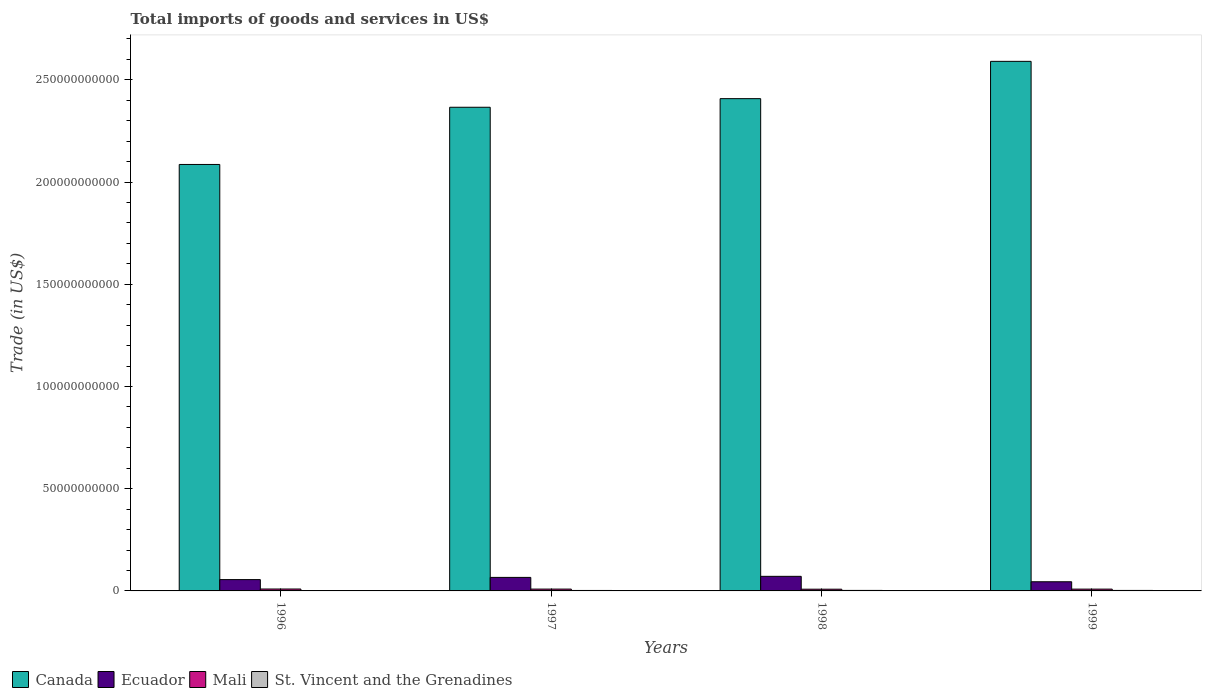How many groups of bars are there?
Keep it short and to the point. 4. How many bars are there on the 4th tick from the right?
Offer a terse response. 4. What is the label of the 3rd group of bars from the left?
Offer a very short reply. 1998. In how many cases, is the number of bars for a given year not equal to the number of legend labels?
Offer a very short reply. 0. What is the total imports of goods and services in Mali in 1998?
Make the answer very short. 8.45e+08. Across all years, what is the maximum total imports of goods and services in Canada?
Give a very brief answer. 2.59e+11. Across all years, what is the minimum total imports of goods and services in Ecuador?
Provide a short and direct response. 4.48e+09. In which year was the total imports of goods and services in Ecuador minimum?
Your response must be concise. 1999. What is the total total imports of goods and services in St. Vincent and the Grenadines in the graph?
Your answer should be compact. 9.04e+08. What is the difference between the total imports of goods and services in Ecuador in 1997 and that in 1999?
Offer a terse response. 2.13e+09. What is the difference between the total imports of goods and services in Ecuador in 1996 and the total imports of goods and services in Mali in 1999?
Provide a short and direct response. 4.65e+09. What is the average total imports of goods and services in St. Vincent and the Grenadines per year?
Offer a very short reply. 2.26e+08. In the year 1999, what is the difference between the total imports of goods and services in Ecuador and total imports of goods and services in Canada?
Offer a terse response. -2.55e+11. In how many years, is the total imports of goods and services in Canada greater than 180000000000 US$?
Your answer should be very brief. 4. What is the ratio of the total imports of goods and services in St. Vincent and the Grenadines in 1996 to that in 1997?
Your answer should be compact. 0.81. Is the difference between the total imports of goods and services in Ecuador in 1996 and 1998 greater than the difference between the total imports of goods and services in Canada in 1996 and 1998?
Offer a very short reply. Yes. What is the difference between the highest and the second highest total imports of goods and services in St. Vincent and the Grenadines?
Provide a short and direct response. 9.04e+06. What is the difference between the highest and the lowest total imports of goods and services in Canada?
Your answer should be compact. 5.04e+1. In how many years, is the total imports of goods and services in Canada greater than the average total imports of goods and services in Canada taken over all years?
Your answer should be very brief. 3. What does the 3rd bar from the right in 1996 represents?
Your answer should be compact. Ecuador. How many bars are there?
Offer a very short reply. 16. How many years are there in the graph?
Offer a terse response. 4. Does the graph contain any zero values?
Give a very brief answer. No. Where does the legend appear in the graph?
Your answer should be very brief. Bottom left. How many legend labels are there?
Keep it short and to the point. 4. What is the title of the graph?
Your answer should be compact. Total imports of goods and services in US$. What is the label or title of the Y-axis?
Your answer should be very brief. Trade (in US$). What is the Trade (in US$) of Canada in 1996?
Keep it short and to the point. 2.09e+11. What is the Trade (in US$) of Ecuador in 1996?
Provide a succinct answer. 5.54e+09. What is the Trade (in US$) in Mali in 1996?
Provide a succinct answer. 9.35e+08. What is the Trade (in US$) of St. Vincent and the Grenadines in 1996?
Your response must be concise. 1.86e+08. What is the Trade (in US$) in Canada in 1997?
Your answer should be very brief. 2.37e+11. What is the Trade (in US$) of Ecuador in 1997?
Offer a terse response. 6.61e+09. What is the Trade (in US$) in Mali in 1997?
Ensure brevity in your answer.  8.96e+08. What is the Trade (in US$) of St. Vincent and the Grenadines in 1997?
Ensure brevity in your answer.  2.29e+08. What is the Trade (in US$) in Canada in 1998?
Offer a terse response. 2.41e+11. What is the Trade (in US$) of Ecuador in 1998?
Provide a short and direct response. 7.14e+09. What is the Trade (in US$) of Mali in 1998?
Your response must be concise. 8.45e+08. What is the Trade (in US$) of St. Vincent and the Grenadines in 1998?
Provide a short and direct response. 2.49e+08. What is the Trade (in US$) of Canada in 1999?
Ensure brevity in your answer.  2.59e+11. What is the Trade (in US$) in Ecuador in 1999?
Give a very brief answer. 4.48e+09. What is the Trade (in US$) of Mali in 1999?
Provide a succinct answer. 8.84e+08. What is the Trade (in US$) in St. Vincent and the Grenadines in 1999?
Give a very brief answer. 2.40e+08. Across all years, what is the maximum Trade (in US$) of Canada?
Offer a terse response. 2.59e+11. Across all years, what is the maximum Trade (in US$) in Ecuador?
Keep it short and to the point. 7.14e+09. Across all years, what is the maximum Trade (in US$) in Mali?
Your response must be concise. 9.35e+08. Across all years, what is the maximum Trade (in US$) in St. Vincent and the Grenadines?
Offer a very short reply. 2.49e+08. Across all years, what is the minimum Trade (in US$) in Canada?
Provide a short and direct response. 2.09e+11. Across all years, what is the minimum Trade (in US$) in Ecuador?
Offer a very short reply. 4.48e+09. Across all years, what is the minimum Trade (in US$) of Mali?
Keep it short and to the point. 8.45e+08. Across all years, what is the minimum Trade (in US$) of St. Vincent and the Grenadines?
Provide a succinct answer. 1.86e+08. What is the total Trade (in US$) of Canada in the graph?
Give a very brief answer. 9.45e+11. What is the total Trade (in US$) in Ecuador in the graph?
Offer a very short reply. 2.38e+1. What is the total Trade (in US$) in Mali in the graph?
Keep it short and to the point. 3.56e+09. What is the total Trade (in US$) in St. Vincent and the Grenadines in the graph?
Provide a succinct answer. 9.04e+08. What is the difference between the Trade (in US$) of Canada in 1996 and that in 1997?
Keep it short and to the point. -2.80e+1. What is the difference between the Trade (in US$) in Ecuador in 1996 and that in 1997?
Provide a short and direct response. -1.08e+09. What is the difference between the Trade (in US$) of Mali in 1996 and that in 1997?
Your response must be concise. 3.91e+07. What is the difference between the Trade (in US$) of St. Vincent and the Grenadines in 1996 and that in 1997?
Give a very brief answer. -4.27e+07. What is the difference between the Trade (in US$) in Canada in 1996 and that in 1998?
Your response must be concise. -3.22e+1. What is the difference between the Trade (in US$) in Ecuador in 1996 and that in 1998?
Make the answer very short. -1.60e+09. What is the difference between the Trade (in US$) of Mali in 1996 and that in 1998?
Offer a terse response. 9.02e+07. What is the difference between the Trade (in US$) of St. Vincent and the Grenadines in 1996 and that in 1998?
Provide a succinct answer. -6.27e+07. What is the difference between the Trade (in US$) of Canada in 1996 and that in 1999?
Give a very brief answer. -5.04e+1. What is the difference between the Trade (in US$) of Ecuador in 1996 and that in 1999?
Your response must be concise. 1.05e+09. What is the difference between the Trade (in US$) in Mali in 1996 and that in 1999?
Make the answer very short. 5.07e+07. What is the difference between the Trade (in US$) in St. Vincent and the Grenadines in 1996 and that in 1999?
Ensure brevity in your answer.  -5.37e+07. What is the difference between the Trade (in US$) of Canada in 1997 and that in 1998?
Offer a very short reply. -4.21e+09. What is the difference between the Trade (in US$) in Ecuador in 1997 and that in 1998?
Ensure brevity in your answer.  -5.23e+08. What is the difference between the Trade (in US$) in Mali in 1997 and that in 1998?
Provide a succinct answer. 5.10e+07. What is the difference between the Trade (in US$) of St. Vincent and the Grenadines in 1997 and that in 1998?
Make the answer very short. -2.01e+07. What is the difference between the Trade (in US$) of Canada in 1997 and that in 1999?
Offer a very short reply. -2.25e+1. What is the difference between the Trade (in US$) in Ecuador in 1997 and that in 1999?
Provide a short and direct response. 2.13e+09. What is the difference between the Trade (in US$) of Mali in 1997 and that in 1999?
Provide a succinct answer. 1.15e+07. What is the difference between the Trade (in US$) in St. Vincent and the Grenadines in 1997 and that in 1999?
Keep it short and to the point. -1.10e+07. What is the difference between the Trade (in US$) of Canada in 1998 and that in 1999?
Provide a succinct answer. -1.82e+1. What is the difference between the Trade (in US$) of Ecuador in 1998 and that in 1999?
Offer a terse response. 2.65e+09. What is the difference between the Trade (in US$) of Mali in 1998 and that in 1999?
Your response must be concise. -3.95e+07. What is the difference between the Trade (in US$) in St. Vincent and the Grenadines in 1998 and that in 1999?
Give a very brief answer. 9.04e+06. What is the difference between the Trade (in US$) in Canada in 1996 and the Trade (in US$) in Ecuador in 1997?
Your answer should be very brief. 2.02e+11. What is the difference between the Trade (in US$) of Canada in 1996 and the Trade (in US$) of Mali in 1997?
Your answer should be compact. 2.08e+11. What is the difference between the Trade (in US$) of Canada in 1996 and the Trade (in US$) of St. Vincent and the Grenadines in 1997?
Your answer should be very brief. 2.08e+11. What is the difference between the Trade (in US$) of Ecuador in 1996 and the Trade (in US$) of Mali in 1997?
Provide a short and direct response. 4.64e+09. What is the difference between the Trade (in US$) in Ecuador in 1996 and the Trade (in US$) in St. Vincent and the Grenadines in 1997?
Ensure brevity in your answer.  5.31e+09. What is the difference between the Trade (in US$) of Mali in 1996 and the Trade (in US$) of St. Vincent and the Grenadines in 1997?
Your answer should be very brief. 7.06e+08. What is the difference between the Trade (in US$) in Canada in 1996 and the Trade (in US$) in Ecuador in 1998?
Give a very brief answer. 2.01e+11. What is the difference between the Trade (in US$) in Canada in 1996 and the Trade (in US$) in Mali in 1998?
Your answer should be compact. 2.08e+11. What is the difference between the Trade (in US$) in Canada in 1996 and the Trade (in US$) in St. Vincent and the Grenadines in 1998?
Offer a terse response. 2.08e+11. What is the difference between the Trade (in US$) in Ecuador in 1996 and the Trade (in US$) in Mali in 1998?
Your answer should be very brief. 4.69e+09. What is the difference between the Trade (in US$) in Ecuador in 1996 and the Trade (in US$) in St. Vincent and the Grenadines in 1998?
Your answer should be compact. 5.29e+09. What is the difference between the Trade (in US$) in Mali in 1996 and the Trade (in US$) in St. Vincent and the Grenadines in 1998?
Ensure brevity in your answer.  6.86e+08. What is the difference between the Trade (in US$) in Canada in 1996 and the Trade (in US$) in Ecuador in 1999?
Ensure brevity in your answer.  2.04e+11. What is the difference between the Trade (in US$) of Canada in 1996 and the Trade (in US$) of Mali in 1999?
Your response must be concise. 2.08e+11. What is the difference between the Trade (in US$) of Canada in 1996 and the Trade (in US$) of St. Vincent and the Grenadines in 1999?
Your answer should be very brief. 2.08e+11. What is the difference between the Trade (in US$) in Ecuador in 1996 and the Trade (in US$) in Mali in 1999?
Offer a very short reply. 4.65e+09. What is the difference between the Trade (in US$) of Ecuador in 1996 and the Trade (in US$) of St. Vincent and the Grenadines in 1999?
Keep it short and to the point. 5.30e+09. What is the difference between the Trade (in US$) of Mali in 1996 and the Trade (in US$) of St. Vincent and the Grenadines in 1999?
Your response must be concise. 6.95e+08. What is the difference between the Trade (in US$) in Canada in 1997 and the Trade (in US$) in Ecuador in 1998?
Keep it short and to the point. 2.29e+11. What is the difference between the Trade (in US$) of Canada in 1997 and the Trade (in US$) of Mali in 1998?
Make the answer very short. 2.36e+11. What is the difference between the Trade (in US$) in Canada in 1997 and the Trade (in US$) in St. Vincent and the Grenadines in 1998?
Ensure brevity in your answer.  2.36e+11. What is the difference between the Trade (in US$) in Ecuador in 1997 and the Trade (in US$) in Mali in 1998?
Make the answer very short. 5.77e+09. What is the difference between the Trade (in US$) in Ecuador in 1997 and the Trade (in US$) in St. Vincent and the Grenadines in 1998?
Provide a short and direct response. 6.36e+09. What is the difference between the Trade (in US$) of Mali in 1997 and the Trade (in US$) of St. Vincent and the Grenadines in 1998?
Provide a short and direct response. 6.47e+08. What is the difference between the Trade (in US$) of Canada in 1997 and the Trade (in US$) of Ecuador in 1999?
Make the answer very short. 2.32e+11. What is the difference between the Trade (in US$) in Canada in 1997 and the Trade (in US$) in Mali in 1999?
Keep it short and to the point. 2.36e+11. What is the difference between the Trade (in US$) in Canada in 1997 and the Trade (in US$) in St. Vincent and the Grenadines in 1999?
Provide a short and direct response. 2.36e+11. What is the difference between the Trade (in US$) in Ecuador in 1997 and the Trade (in US$) in Mali in 1999?
Keep it short and to the point. 5.73e+09. What is the difference between the Trade (in US$) of Ecuador in 1997 and the Trade (in US$) of St. Vincent and the Grenadines in 1999?
Your answer should be very brief. 6.37e+09. What is the difference between the Trade (in US$) in Mali in 1997 and the Trade (in US$) in St. Vincent and the Grenadines in 1999?
Ensure brevity in your answer.  6.56e+08. What is the difference between the Trade (in US$) in Canada in 1998 and the Trade (in US$) in Ecuador in 1999?
Offer a very short reply. 2.36e+11. What is the difference between the Trade (in US$) of Canada in 1998 and the Trade (in US$) of Mali in 1999?
Offer a terse response. 2.40e+11. What is the difference between the Trade (in US$) of Canada in 1998 and the Trade (in US$) of St. Vincent and the Grenadines in 1999?
Give a very brief answer. 2.41e+11. What is the difference between the Trade (in US$) in Ecuador in 1998 and the Trade (in US$) in Mali in 1999?
Your answer should be very brief. 6.25e+09. What is the difference between the Trade (in US$) in Ecuador in 1998 and the Trade (in US$) in St. Vincent and the Grenadines in 1999?
Offer a very short reply. 6.90e+09. What is the difference between the Trade (in US$) of Mali in 1998 and the Trade (in US$) of St. Vincent and the Grenadines in 1999?
Provide a short and direct response. 6.05e+08. What is the average Trade (in US$) of Canada per year?
Offer a very short reply. 2.36e+11. What is the average Trade (in US$) in Ecuador per year?
Keep it short and to the point. 5.94e+09. What is the average Trade (in US$) of Mali per year?
Offer a terse response. 8.90e+08. What is the average Trade (in US$) in St. Vincent and the Grenadines per year?
Provide a succinct answer. 2.26e+08. In the year 1996, what is the difference between the Trade (in US$) of Canada and Trade (in US$) of Ecuador?
Give a very brief answer. 2.03e+11. In the year 1996, what is the difference between the Trade (in US$) of Canada and Trade (in US$) of Mali?
Provide a short and direct response. 2.08e+11. In the year 1996, what is the difference between the Trade (in US$) of Canada and Trade (in US$) of St. Vincent and the Grenadines?
Offer a very short reply. 2.08e+11. In the year 1996, what is the difference between the Trade (in US$) in Ecuador and Trade (in US$) in Mali?
Offer a very short reply. 4.60e+09. In the year 1996, what is the difference between the Trade (in US$) in Ecuador and Trade (in US$) in St. Vincent and the Grenadines?
Ensure brevity in your answer.  5.35e+09. In the year 1996, what is the difference between the Trade (in US$) of Mali and Trade (in US$) of St. Vincent and the Grenadines?
Provide a succinct answer. 7.49e+08. In the year 1997, what is the difference between the Trade (in US$) in Canada and Trade (in US$) in Ecuador?
Keep it short and to the point. 2.30e+11. In the year 1997, what is the difference between the Trade (in US$) of Canada and Trade (in US$) of Mali?
Keep it short and to the point. 2.36e+11. In the year 1997, what is the difference between the Trade (in US$) in Canada and Trade (in US$) in St. Vincent and the Grenadines?
Offer a very short reply. 2.36e+11. In the year 1997, what is the difference between the Trade (in US$) of Ecuador and Trade (in US$) of Mali?
Offer a very short reply. 5.72e+09. In the year 1997, what is the difference between the Trade (in US$) of Ecuador and Trade (in US$) of St. Vincent and the Grenadines?
Provide a short and direct response. 6.38e+09. In the year 1997, what is the difference between the Trade (in US$) of Mali and Trade (in US$) of St. Vincent and the Grenadines?
Ensure brevity in your answer.  6.67e+08. In the year 1998, what is the difference between the Trade (in US$) of Canada and Trade (in US$) of Ecuador?
Provide a succinct answer. 2.34e+11. In the year 1998, what is the difference between the Trade (in US$) in Canada and Trade (in US$) in Mali?
Give a very brief answer. 2.40e+11. In the year 1998, what is the difference between the Trade (in US$) in Canada and Trade (in US$) in St. Vincent and the Grenadines?
Provide a succinct answer. 2.41e+11. In the year 1998, what is the difference between the Trade (in US$) in Ecuador and Trade (in US$) in Mali?
Give a very brief answer. 6.29e+09. In the year 1998, what is the difference between the Trade (in US$) in Ecuador and Trade (in US$) in St. Vincent and the Grenadines?
Provide a short and direct response. 6.89e+09. In the year 1998, what is the difference between the Trade (in US$) of Mali and Trade (in US$) of St. Vincent and the Grenadines?
Give a very brief answer. 5.96e+08. In the year 1999, what is the difference between the Trade (in US$) of Canada and Trade (in US$) of Ecuador?
Give a very brief answer. 2.55e+11. In the year 1999, what is the difference between the Trade (in US$) in Canada and Trade (in US$) in Mali?
Keep it short and to the point. 2.58e+11. In the year 1999, what is the difference between the Trade (in US$) of Canada and Trade (in US$) of St. Vincent and the Grenadines?
Offer a very short reply. 2.59e+11. In the year 1999, what is the difference between the Trade (in US$) of Ecuador and Trade (in US$) of Mali?
Your answer should be very brief. 3.60e+09. In the year 1999, what is the difference between the Trade (in US$) of Ecuador and Trade (in US$) of St. Vincent and the Grenadines?
Ensure brevity in your answer.  4.24e+09. In the year 1999, what is the difference between the Trade (in US$) in Mali and Trade (in US$) in St. Vincent and the Grenadines?
Your answer should be compact. 6.44e+08. What is the ratio of the Trade (in US$) in Canada in 1996 to that in 1997?
Make the answer very short. 0.88. What is the ratio of the Trade (in US$) of Ecuador in 1996 to that in 1997?
Ensure brevity in your answer.  0.84. What is the ratio of the Trade (in US$) of Mali in 1996 to that in 1997?
Provide a short and direct response. 1.04. What is the ratio of the Trade (in US$) of St. Vincent and the Grenadines in 1996 to that in 1997?
Your answer should be very brief. 0.81. What is the ratio of the Trade (in US$) in Canada in 1996 to that in 1998?
Give a very brief answer. 0.87. What is the ratio of the Trade (in US$) of Ecuador in 1996 to that in 1998?
Your answer should be very brief. 0.78. What is the ratio of the Trade (in US$) in Mali in 1996 to that in 1998?
Your response must be concise. 1.11. What is the ratio of the Trade (in US$) in St. Vincent and the Grenadines in 1996 to that in 1998?
Provide a short and direct response. 0.75. What is the ratio of the Trade (in US$) of Canada in 1996 to that in 1999?
Make the answer very short. 0.81. What is the ratio of the Trade (in US$) in Ecuador in 1996 to that in 1999?
Make the answer very short. 1.23. What is the ratio of the Trade (in US$) of Mali in 1996 to that in 1999?
Keep it short and to the point. 1.06. What is the ratio of the Trade (in US$) of St. Vincent and the Grenadines in 1996 to that in 1999?
Provide a succinct answer. 0.78. What is the ratio of the Trade (in US$) in Canada in 1997 to that in 1998?
Offer a very short reply. 0.98. What is the ratio of the Trade (in US$) in Ecuador in 1997 to that in 1998?
Keep it short and to the point. 0.93. What is the ratio of the Trade (in US$) in Mali in 1997 to that in 1998?
Your answer should be very brief. 1.06. What is the ratio of the Trade (in US$) in St. Vincent and the Grenadines in 1997 to that in 1998?
Your answer should be compact. 0.92. What is the ratio of the Trade (in US$) in Canada in 1997 to that in 1999?
Provide a succinct answer. 0.91. What is the ratio of the Trade (in US$) in Ecuador in 1997 to that in 1999?
Provide a short and direct response. 1.47. What is the ratio of the Trade (in US$) of Mali in 1997 to that in 1999?
Keep it short and to the point. 1.01. What is the ratio of the Trade (in US$) in St. Vincent and the Grenadines in 1997 to that in 1999?
Give a very brief answer. 0.95. What is the ratio of the Trade (in US$) in Canada in 1998 to that in 1999?
Make the answer very short. 0.93. What is the ratio of the Trade (in US$) of Ecuador in 1998 to that in 1999?
Give a very brief answer. 1.59. What is the ratio of the Trade (in US$) in Mali in 1998 to that in 1999?
Give a very brief answer. 0.96. What is the ratio of the Trade (in US$) of St. Vincent and the Grenadines in 1998 to that in 1999?
Provide a short and direct response. 1.04. What is the difference between the highest and the second highest Trade (in US$) of Canada?
Your answer should be very brief. 1.82e+1. What is the difference between the highest and the second highest Trade (in US$) of Ecuador?
Ensure brevity in your answer.  5.23e+08. What is the difference between the highest and the second highest Trade (in US$) in Mali?
Keep it short and to the point. 3.91e+07. What is the difference between the highest and the second highest Trade (in US$) of St. Vincent and the Grenadines?
Make the answer very short. 9.04e+06. What is the difference between the highest and the lowest Trade (in US$) in Canada?
Ensure brevity in your answer.  5.04e+1. What is the difference between the highest and the lowest Trade (in US$) in Ecuador?
Offer a terse response. 2.65e+09. What is the difference between the highest and the lowest Trade (in US$) in Mali?
Keep it short and to the point. 9.02e+07. What is the difference between the highest and the lowest Trade (in US$) of St. Vincent and the Grenadines?
Offer a terse response. 6.27e+07. 